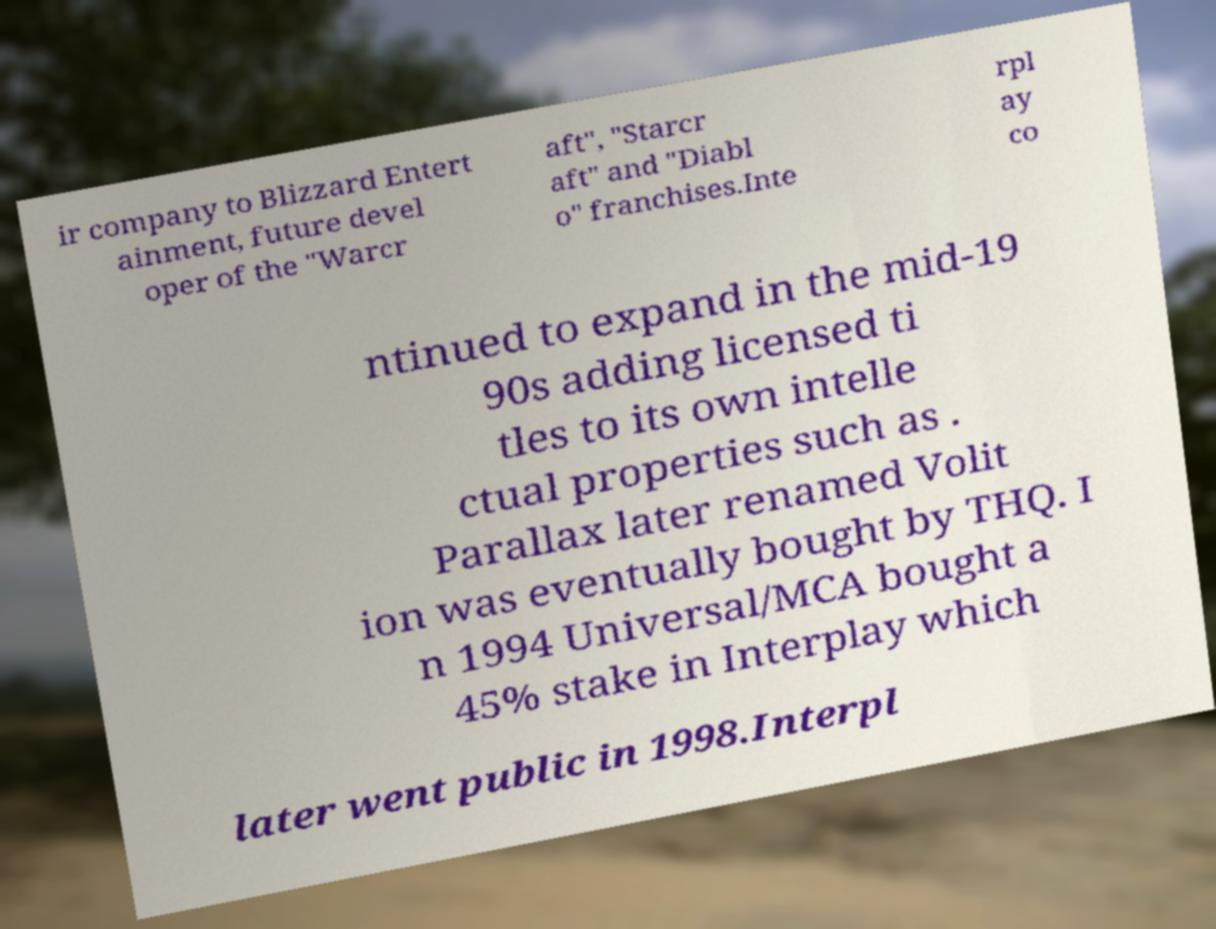For documentation purposes, I need the text within this image transcribed. Could you provide that? ir company to Blizzard Entert ainment, future devel oper of the "Warcr aft", "Starcr aft" and "Diabl o" franchises.Inte rpl ay co ntinued to expand in the mid-19 90s adding licensed ti tles to its own intelle ctual properties such as . Parallax later renamed Volit ion was eventually bought by THQ. I n 1994 Universal/MCA bought a 45% stake in Interplay which later went public in 1998.Interpl 